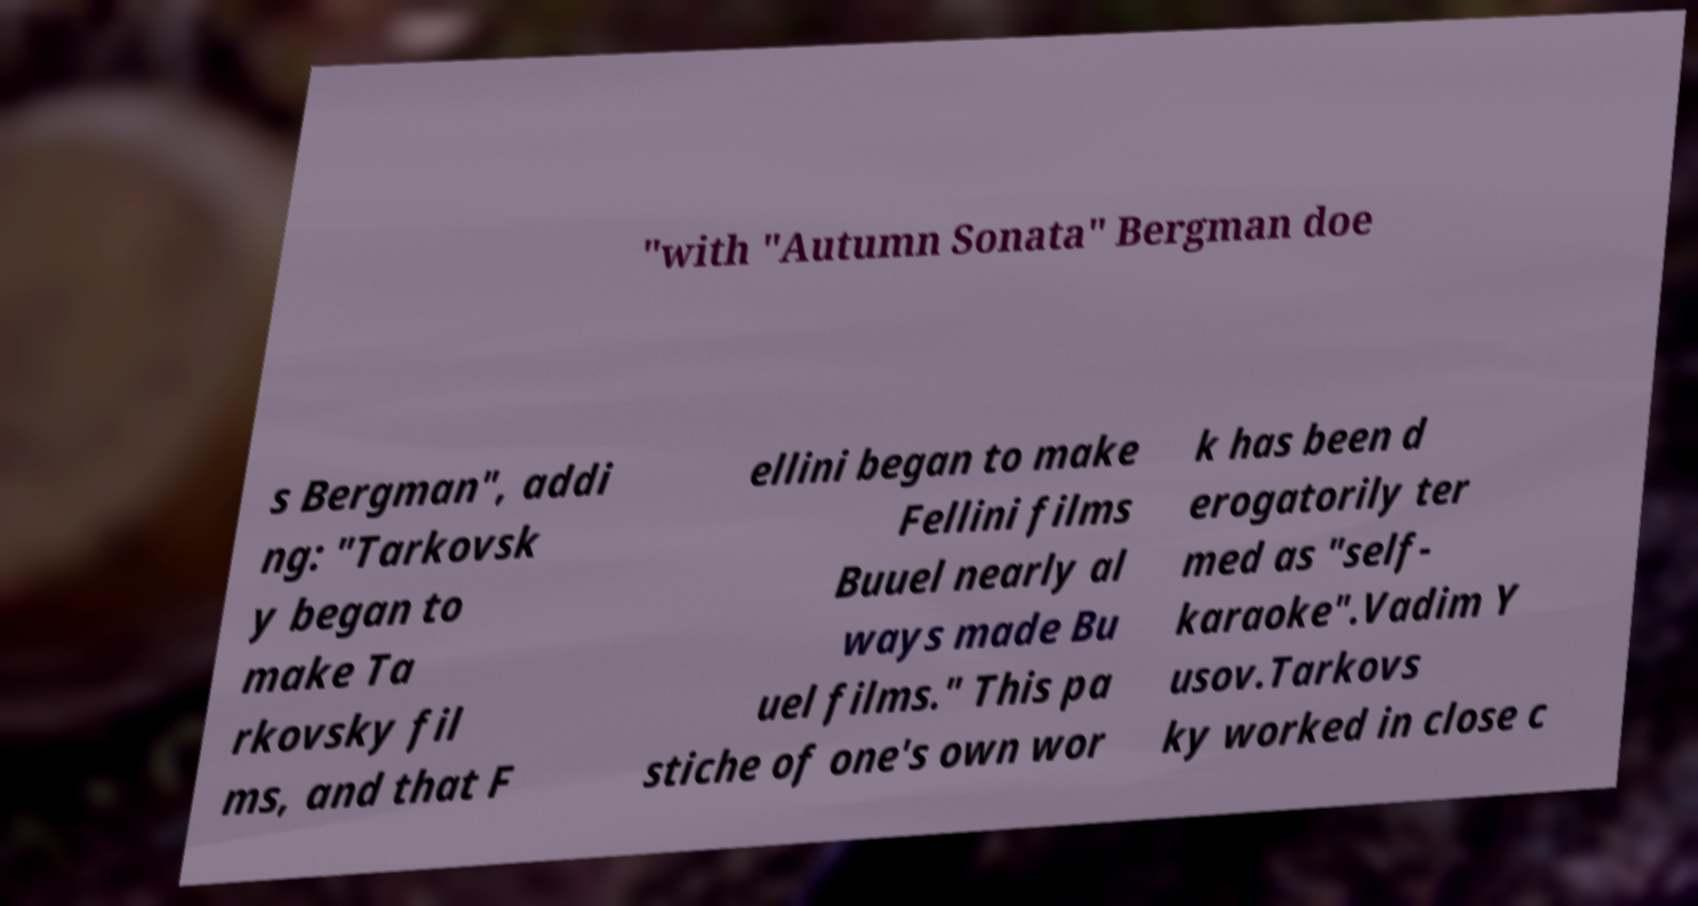Could you extract and type out the text from this image? "with "Autumn Sonata" Bergman doe s Bergman", addi ng: "Tarkovsk y began to make Ta rkovsky fil ms, and that F ellini began to make Fellini films Buuel nearly al ways made Bu uel films." This pa stiche of one's own wor k has been d erogatorily ter med as "self- karaoke".Vadim Y usov.Tarkovs ky worked in close c 